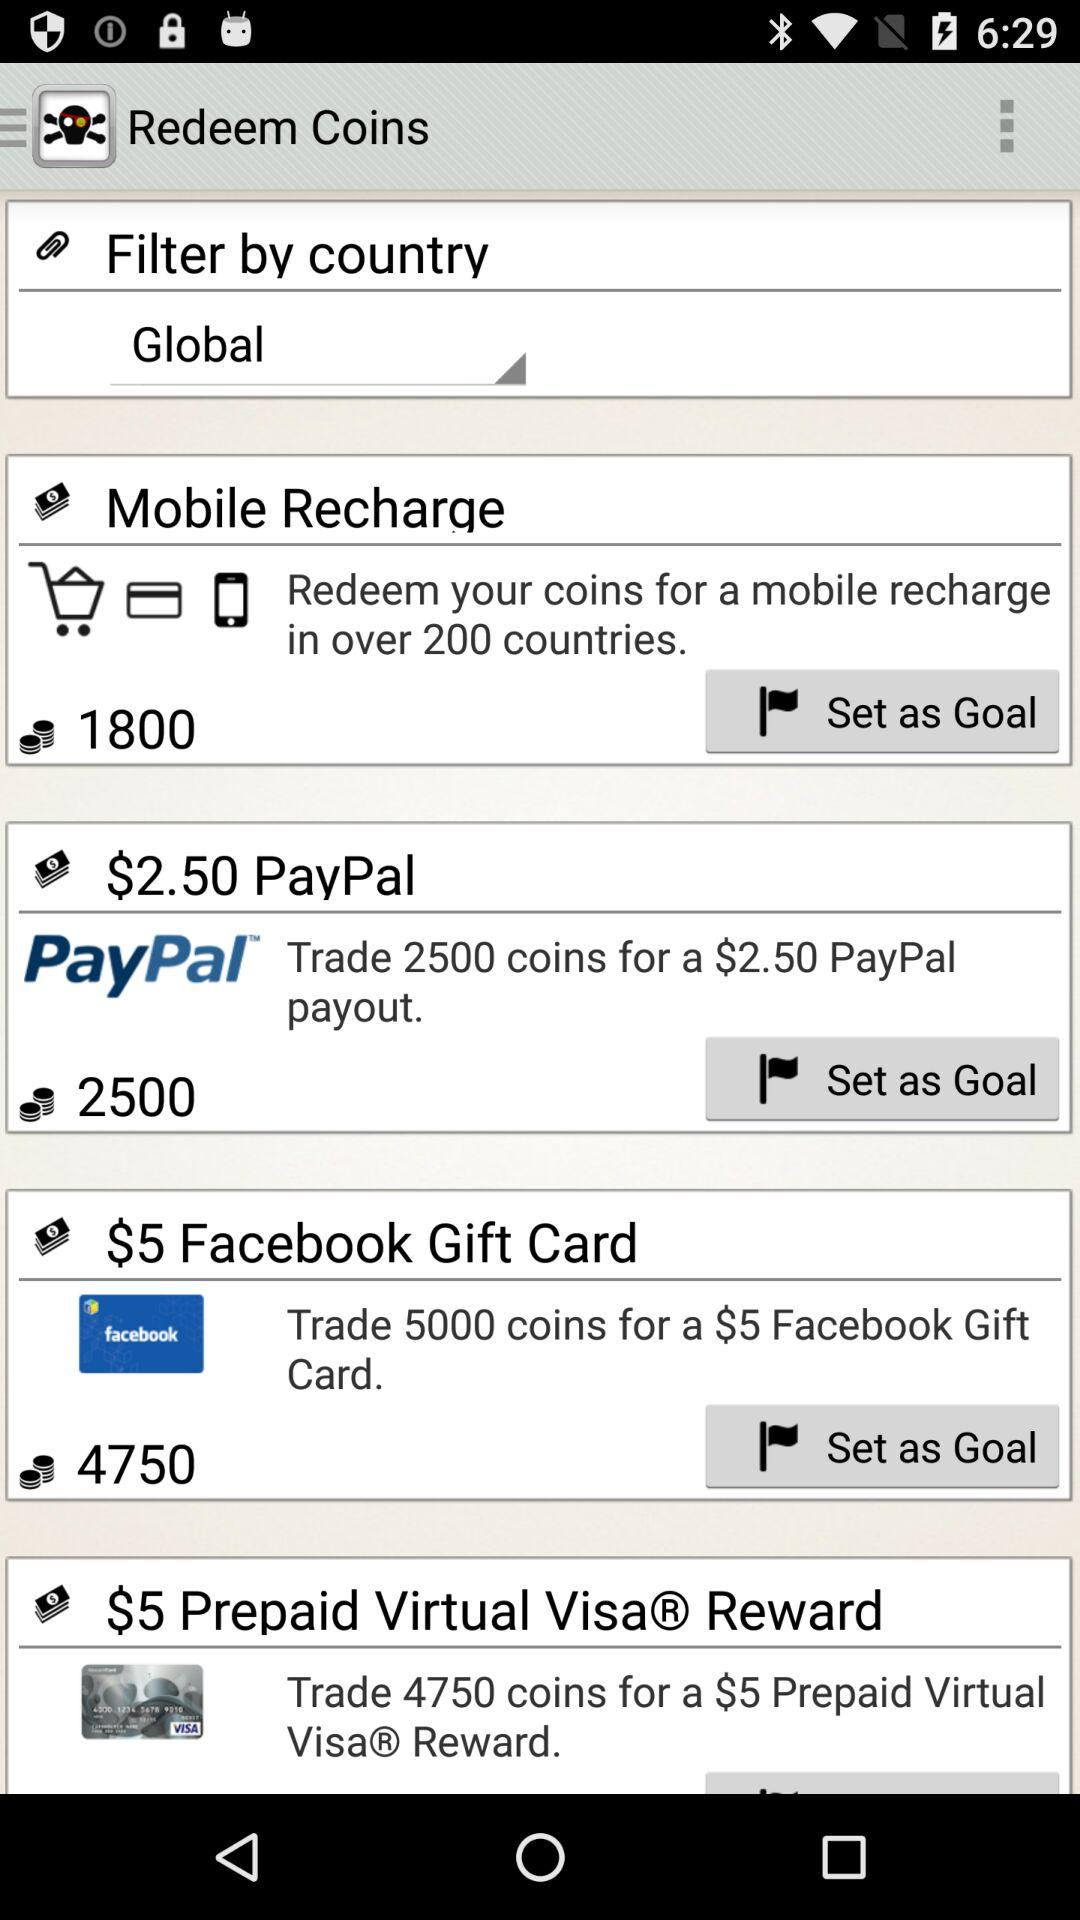In how many countries can we redeem coins for mobile recharge? You can redeem the coins for mobile recharge in over 200 countries. 